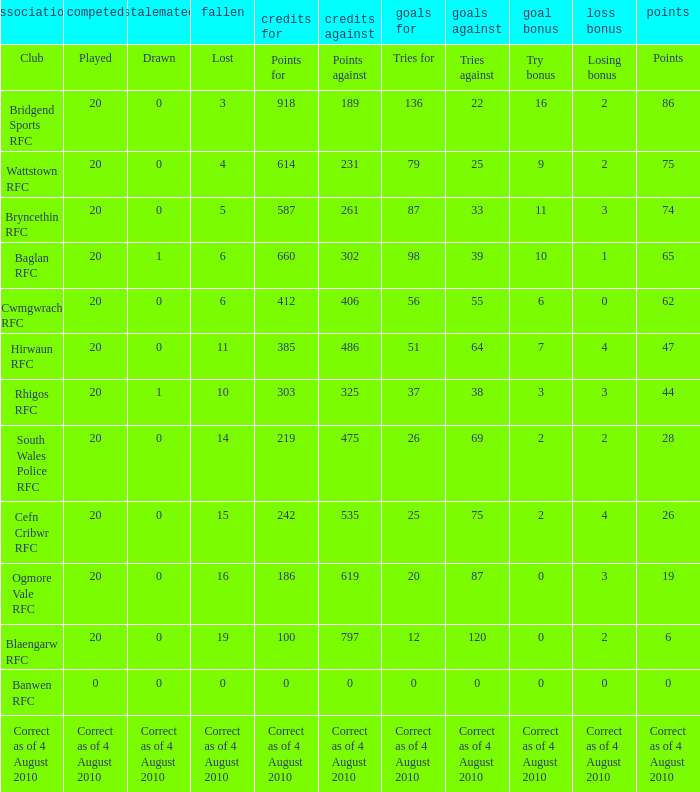What is the points when the club blaengarw rfc? 6.0. 